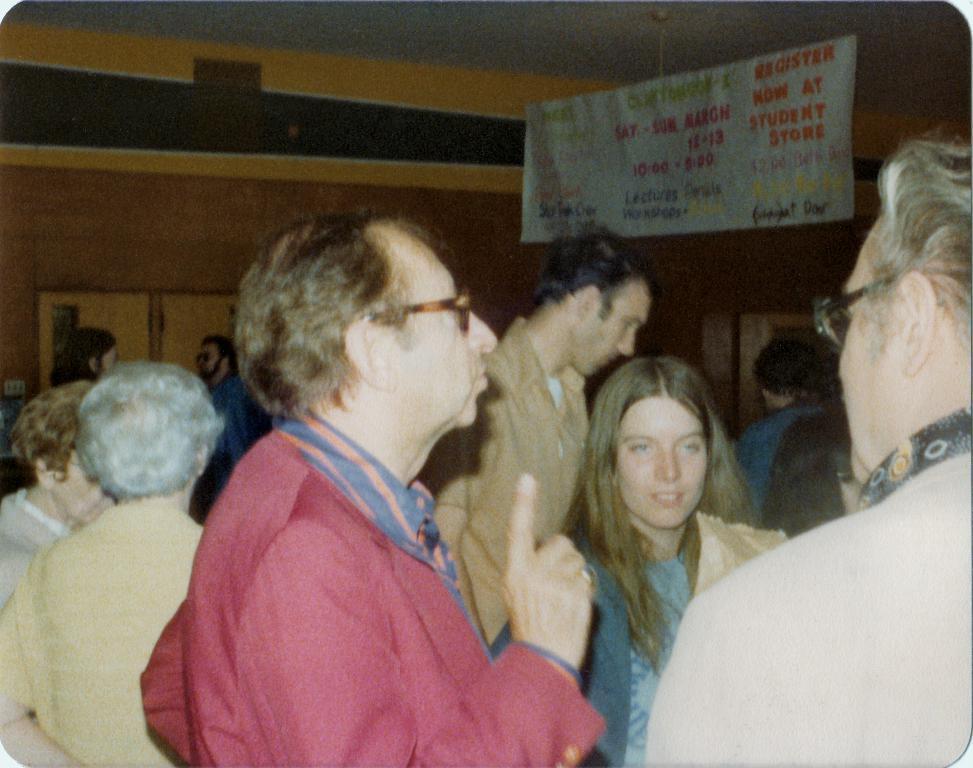In one or two sentences, can you explain what this image depicts? In this image there are many people standing. Behind them there is a wall. There are doors to the wall. At the top there is the ceiling. There is a board with text hanging to the ceiling. 